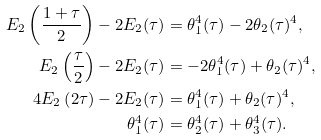<formula> <loc_0><loc_0><loc_500><loc_500>E _ { 2 } \left ( \frac { 1 + \tau } 2 \right ) - 2 E _ { 2 } ( \tau ) & = \theta _ { 1 } ^ { 4 } ( \tau ) - 2 \theta _ { 2 } ( \tau ) ^ { 4 } , \\ E _ { 2 } \left ( \frac { \tau } 2 \right ) - 2 E _ { 2 } ( \tau ) & = - 2 \theta _ { 1 } ^ { 4 } ( \tau ) + \theta _ { 2 } ( \tau ) ^ { 4 } , \\ 4 E _ { 2 } \left ( 2 \tau \right ) - 2 E _ { 2 } ( \tau ) & = \theta _ { 1 } ^ { 4 } ( \tau ) + \theta _ { 2 } ( \tau ) ^ { 4 } , \\ \theta _ { 1 } ^ { 4 } ( \tau ) & = \theta _ { 2 } ^ { 4 } ( \tau ) + \theta _ { 3 } ^ { 4 } ( \tau ) .</formula> 